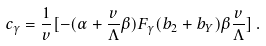Convert formula to latex. <formula><loc_0><loc_0><loc_500><loc_500>c _ { \gamma } = { \frac { 1 } { v } } [ - ( \alpha + { \frac { v } { \Lambda } } \beta ) F _ { \gamma } ( b _ { 2 } + b _ { Y } ) \beta { \frac { v } { \Lambda } } ] \, .</formula> 